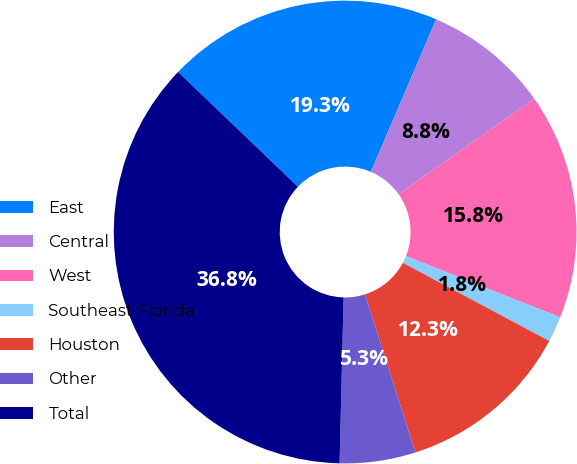Convert chart to OTSL. <chart><loc_0><loc_0><loc_500><loc_500><pie_chart><fcel>East<fcel>Central<fcel>West<fcel>Southeast Florida<fcel>Houston<fcel>Other<fcel>Total<nl><fcel>19.28%<fcel>8.79%<fcel>15.79%<fcel>1.79%<fcel>12.29%<fcel>5.29%<fcel>36.78%<nl></chart> 